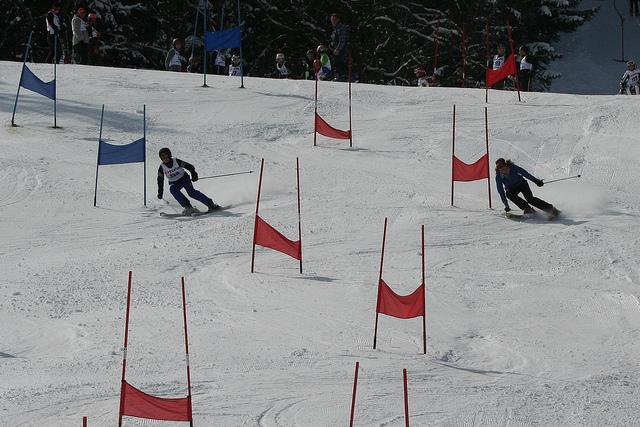Is this a competition?
Give a very brief answer. Yes. What direction are the two skiers leaning in?
Answer briefly. Left. What color are most of the flags?
Concise answer only. Red. 